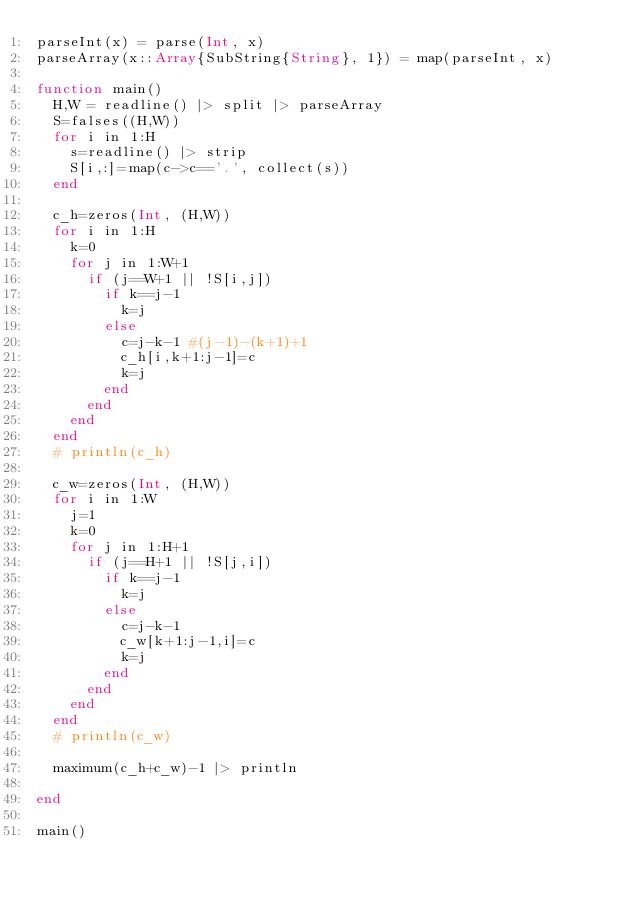Convert code to text. <code><loc_0><loc_0><loc_500><loc_500><_Julia_>parseInt(x) = parse(Int, x)
parseArray(x::Array{SubString{String}, 1}) = map(parseInt, x)

function main()
  H,W = readline() |> split |> parseArray
  S=falses((H,W))
  for i in 1:H
    s=readline() |> strip
    S[i,:]=map(c->c=='.', collect(s))
  end

  c_h=zeros(Int, (H,W))
  for i in 1:H
    k=0
    for j in 1:W+1
      if (j==W+1 || !S[i,j])
        if k==j-1
          k=j
        else
          c=j-k-1 #(j-1)-(k+1)+1
          c_h[i,k+1:j-1]=c
          k=j
        end
      end
    end
  end
  # println(c_h)

  c_w=zeros(Int, (H,W))
  for i in 1:W
    j=1
    k=0
    for j in 1:H+1
      if (j==H+1 || !S[j,i])
        if k==j-1
          k=j
        else
          c=j-k-1
          c_w[k+1:j-1,i]=c
          k=j
        end
      end
    end
  end
  # println(c_w)

  maximum(c_h+c_w)-1 |> println

end

main()
</code> 